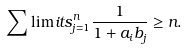<formula> <loc_0><loc_0><loc_500><loc_500>\sum \lim i t s _ { j = 1 } ^ { n } \frac { 1 } { 1 + a _ { i } b _ { j } } \geq n .</formula> 